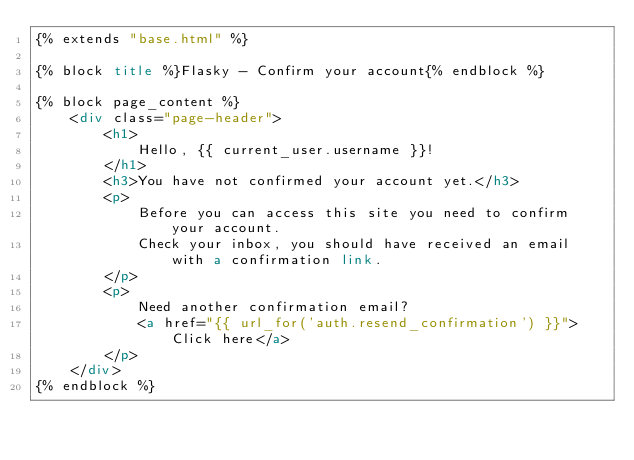<code> <loc_0><loc_0><loc_500><loc_500><_HTML_>{% extends "base.html" %}

{% block title %}Flasky - Confirm your account{% endblock %}

{% block page_content %}
    <div class="page-header">
        <h1>
            Hello, {{ current_user.username }}!
        </h1>
        <h3>You have not confirmed your account yet.</h3>
        <p>
            Before you can access this site you need to confirm your account.
            Check your inbox, you should have received an email with a confirmation link.
        </p>
        <p>
            Need another confirmation email?
            <a href="{{ url_for('auth.resend_confirmation') }}">Click here</a>
        </p>
    </div>
{% endblock %}
</code> 